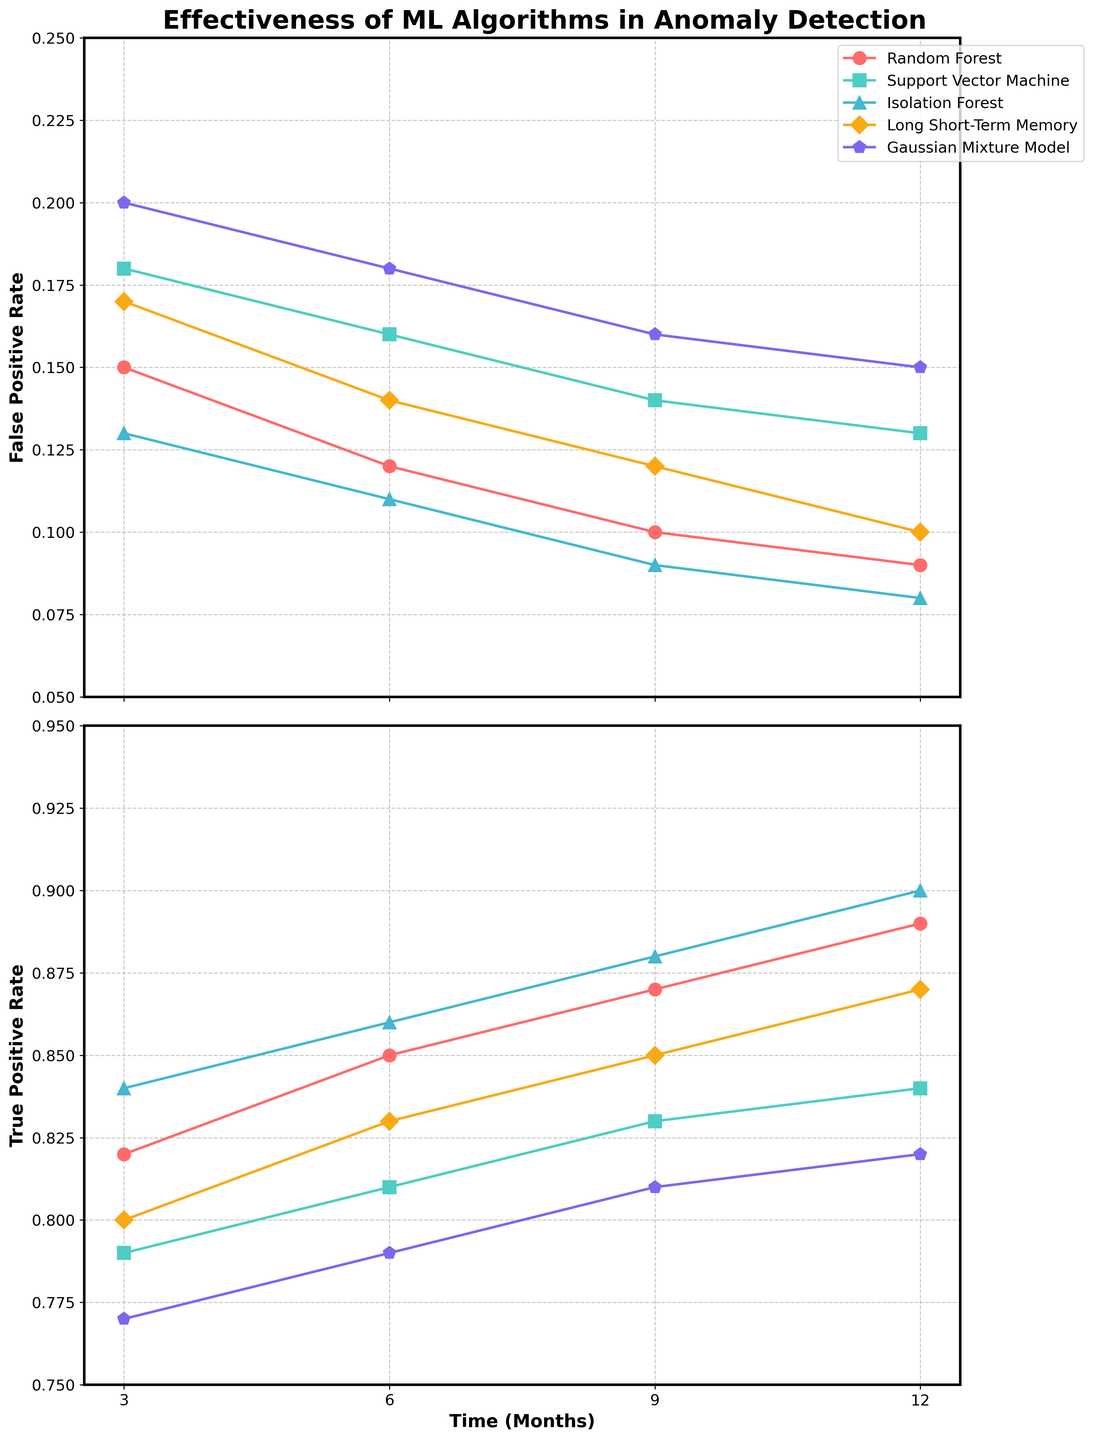What is the trend of the False Positive Rate for the Random Forest algorithm over the 12 months? The False Positive Rate for the Random Forest algorithm decreases over time. Starting from 0.15 at 3 months, it drops to 0.12 at 6 months, 0.10 at 9 months, and further decreases to 0.09 at 12 months.
Answer: Decreasing Which algorithm has the lowest False Positive Rate at 9 months? By comparing the False Positive Rates at 9 months for all algorithms, Isolation Forest has the lowest rate of 0.09.
Answer: Isolation Forest What is the average True Positive Rate for the Long Short-Term Memory algorithm over the 12 months? The True Positive Rates for the Long Short-Term Memory algorithm over the 12 months are 0.80, 0.83, 0.85, and 0.87. Summing these values results in 3.35, and the average is 3.35/4 = 0.8375.
Answer: 0.8375 Compare the True Positive Rates between Isolation Forest and Support Vector Machine at 6 months. Which one is higher? At 6 months, the True Positive Rate for Isolation Forest is 0.86, whereas for Support Vector Machine it is 0.81. Comparing these values, Isolation Forest has the higher True Positive Rate.
Answer: Isolation Forest What color represents the Gaussian Mixture Model in the plot? The Gaussian Mixture Model is represented by the yellow color (as indicated by the color assigned to it in the plot).
Answer: Yellow How does the False Positive Rate of Support Vector Machine change from 3 months to 12 months? Over time, the False Positive Rate of Support Vector Machine decreases. It starts at 0.18 at 3 months, then goes to 0.16 at 6 months, 0.14 at 9 months, and finally decreases to 0.13 at 12 months.
Answer: Decreasing Identify the pair of algorithms with the largest True Positive Rate difference at 3 months and state the difference. At 3 months, the True Positive Rates are 0.82 (Random Forest), 0.79 (Support Vector Machine), 0.84 (Isolation Forest), 0.80 (Long Short-Term Memory), and 0.77 (Gaussian Mixture Model). The largest difference is between Isolation Forest (0.84) and Gaussian Mixture Model (0.77), resulting in 0.84 - 0.77 = 0.07.
Answer: Isolation Forest and Gaussian Mixture Model, 0.07 Which algorithm shows constant improvement in both False Positive Rate and True Positive Rate over the 12 months? By visually inspecting the trends over the 12 months, Isolation Forest consistently shows a decrease in False Positive Rate from 0.13 to 0.08 and an increase in True Positive Rate from 0.84 to 0.90.
Answer: Isolation Forest 